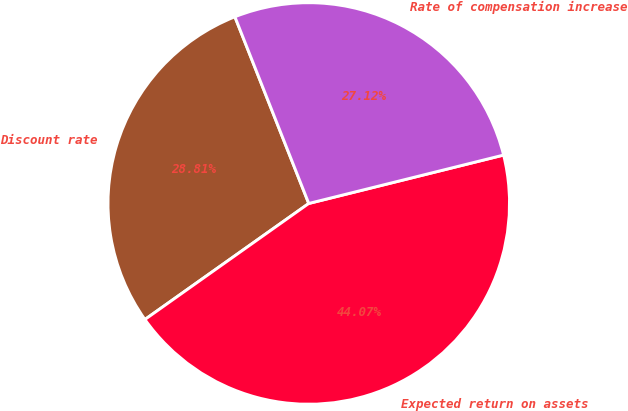<chart> <loc_0><loc_0><loc_500><loc_500><pie_chart><fcel>Discount rate<fcel>Expected return on assets<fcel>Rate of compensation increase<nl><fcel>28.81%<fcel>44.07%<fcel>27.12%<nl></chart> 